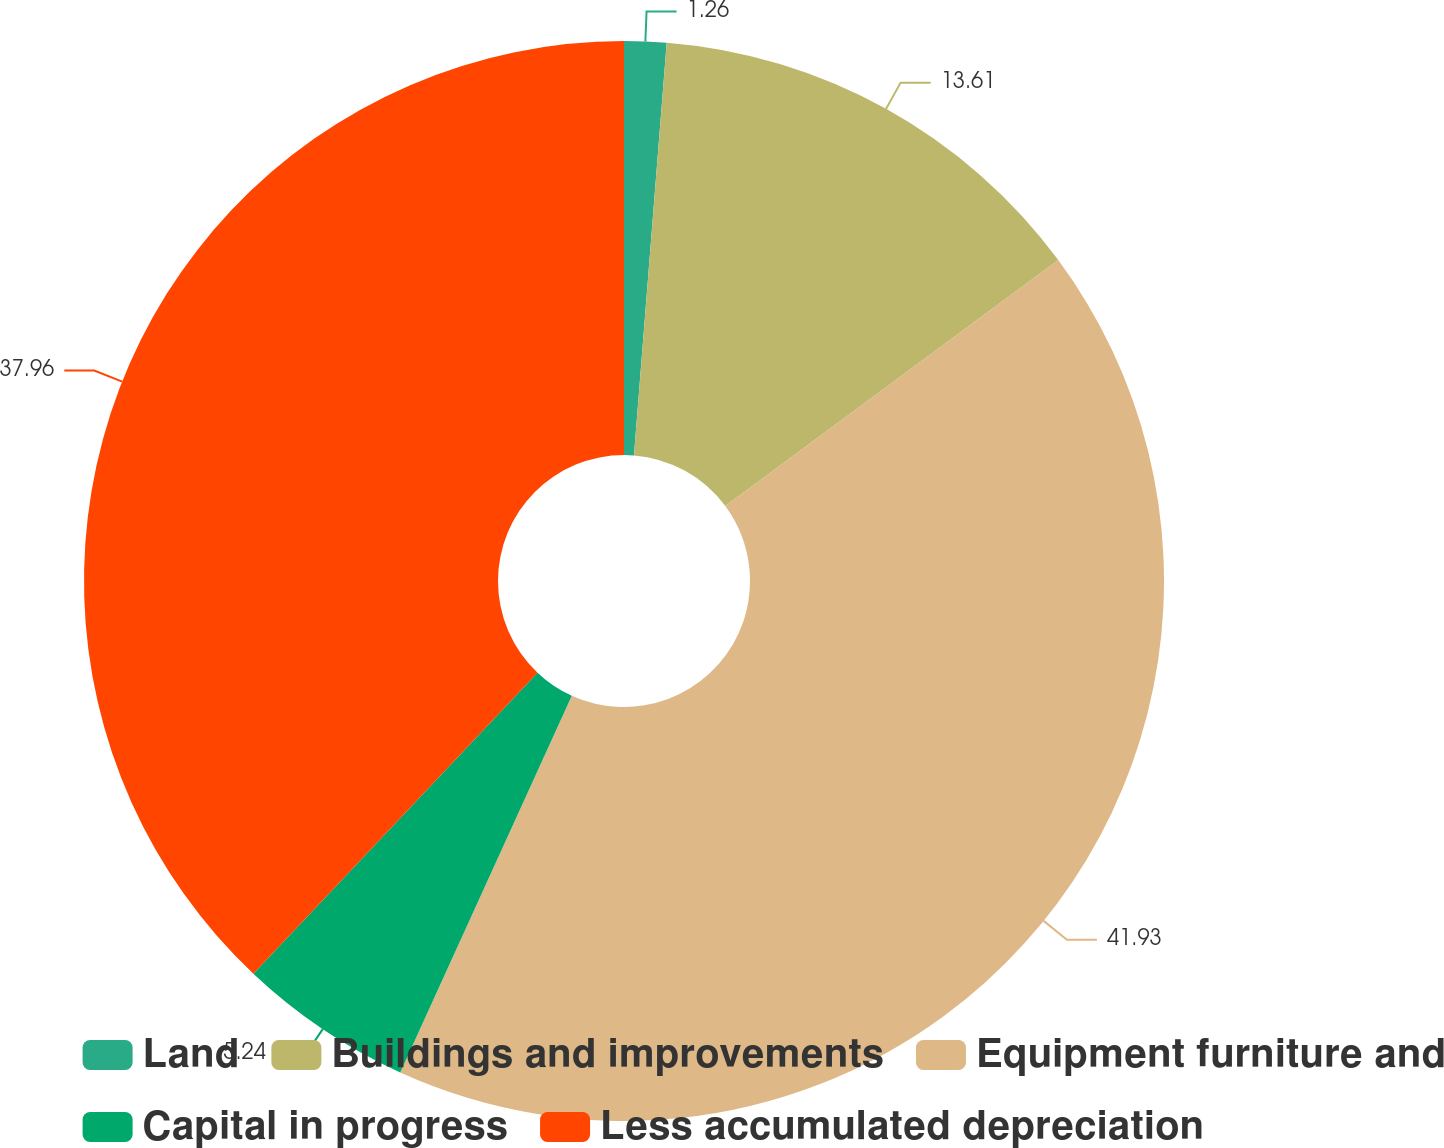Convert chart to OTSL. <chart><loc_0><loc_0><loc_500><loc_500><pie_chart><fcel>Land<fcel>Buildings and improvements<fcel>Equipment furniture and<fcel>Capital in progress<fcel>Less accumulated depreciation<nl><fcel>1.26%<fcel>13.61%<fcel>41.93%<fcel>5.24%<fcel>37.96%<nl></chart> 